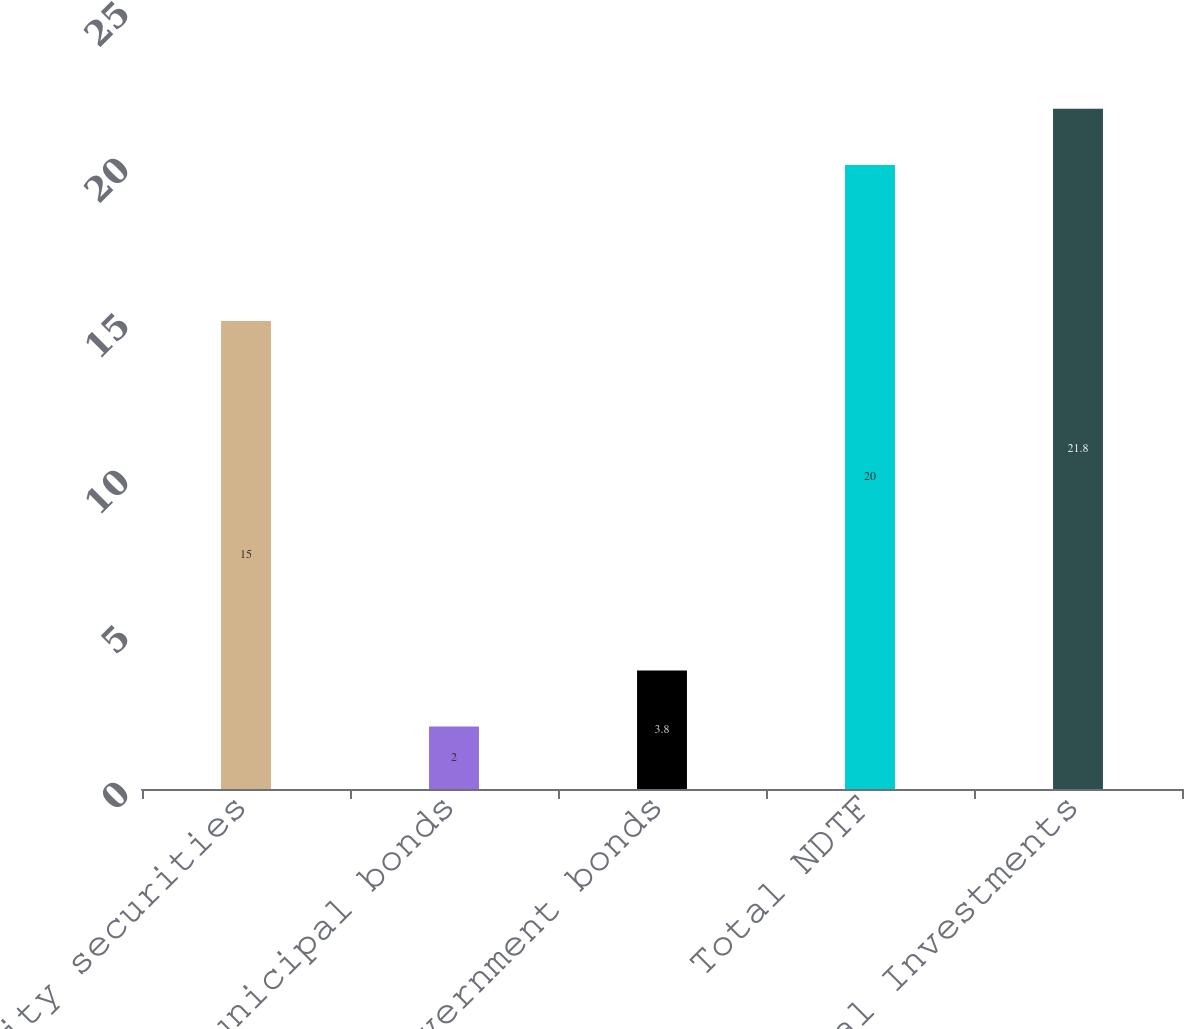Convert chart to OTSL. <chart><loc_0><loc_0><loc_500><loc_500><bar_chart><fcel>Equity securities<fcel>Municipal bonds<fcel>US government bonds<fcel>Total NDTF<fcel>Total Investments<nl><fcel>15<fcel>2<fcel>3.8<fcel>20<fcel>21.8<nl></chart> 